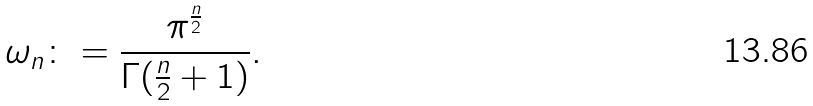<formula> <loc_0><loc_0><loc_500><loc_500>\omega _ { n } \colon = \frac { \pi ^ { \frac { n } { 2 } } } { \Gamma ( \frac { n } { 2 } + 1 ) } .</formula> 